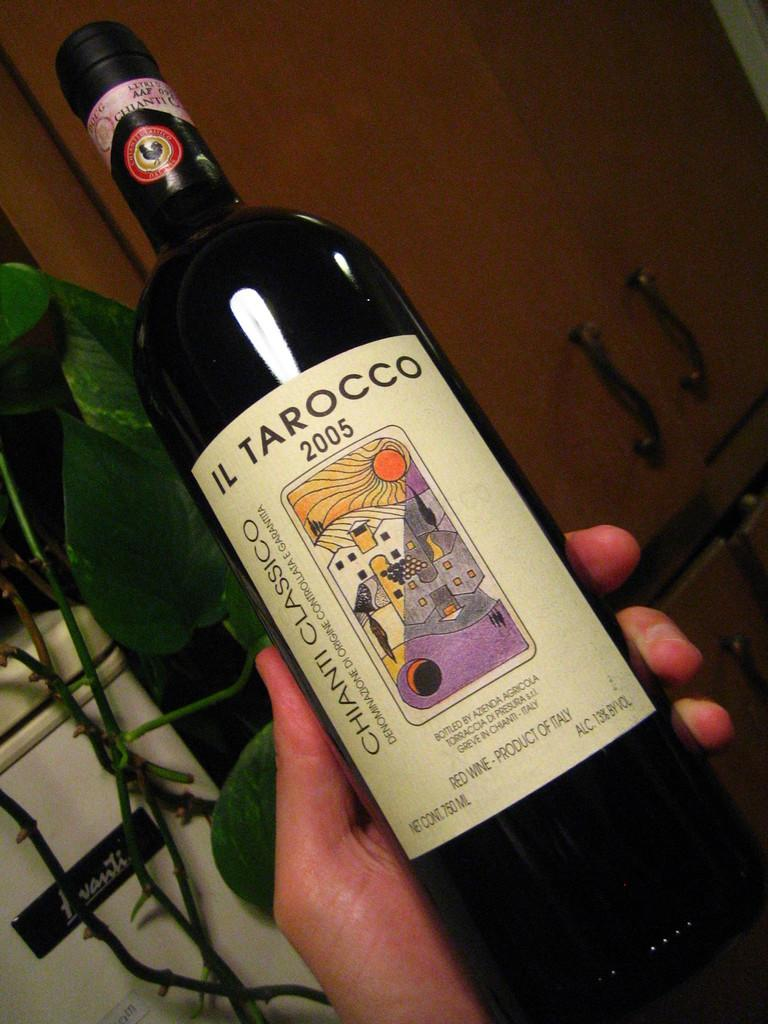<image>
Relay a brief, clear account of the picture shown. A bottle of Il Tarocco 2005 is resting in a person’s hand. 